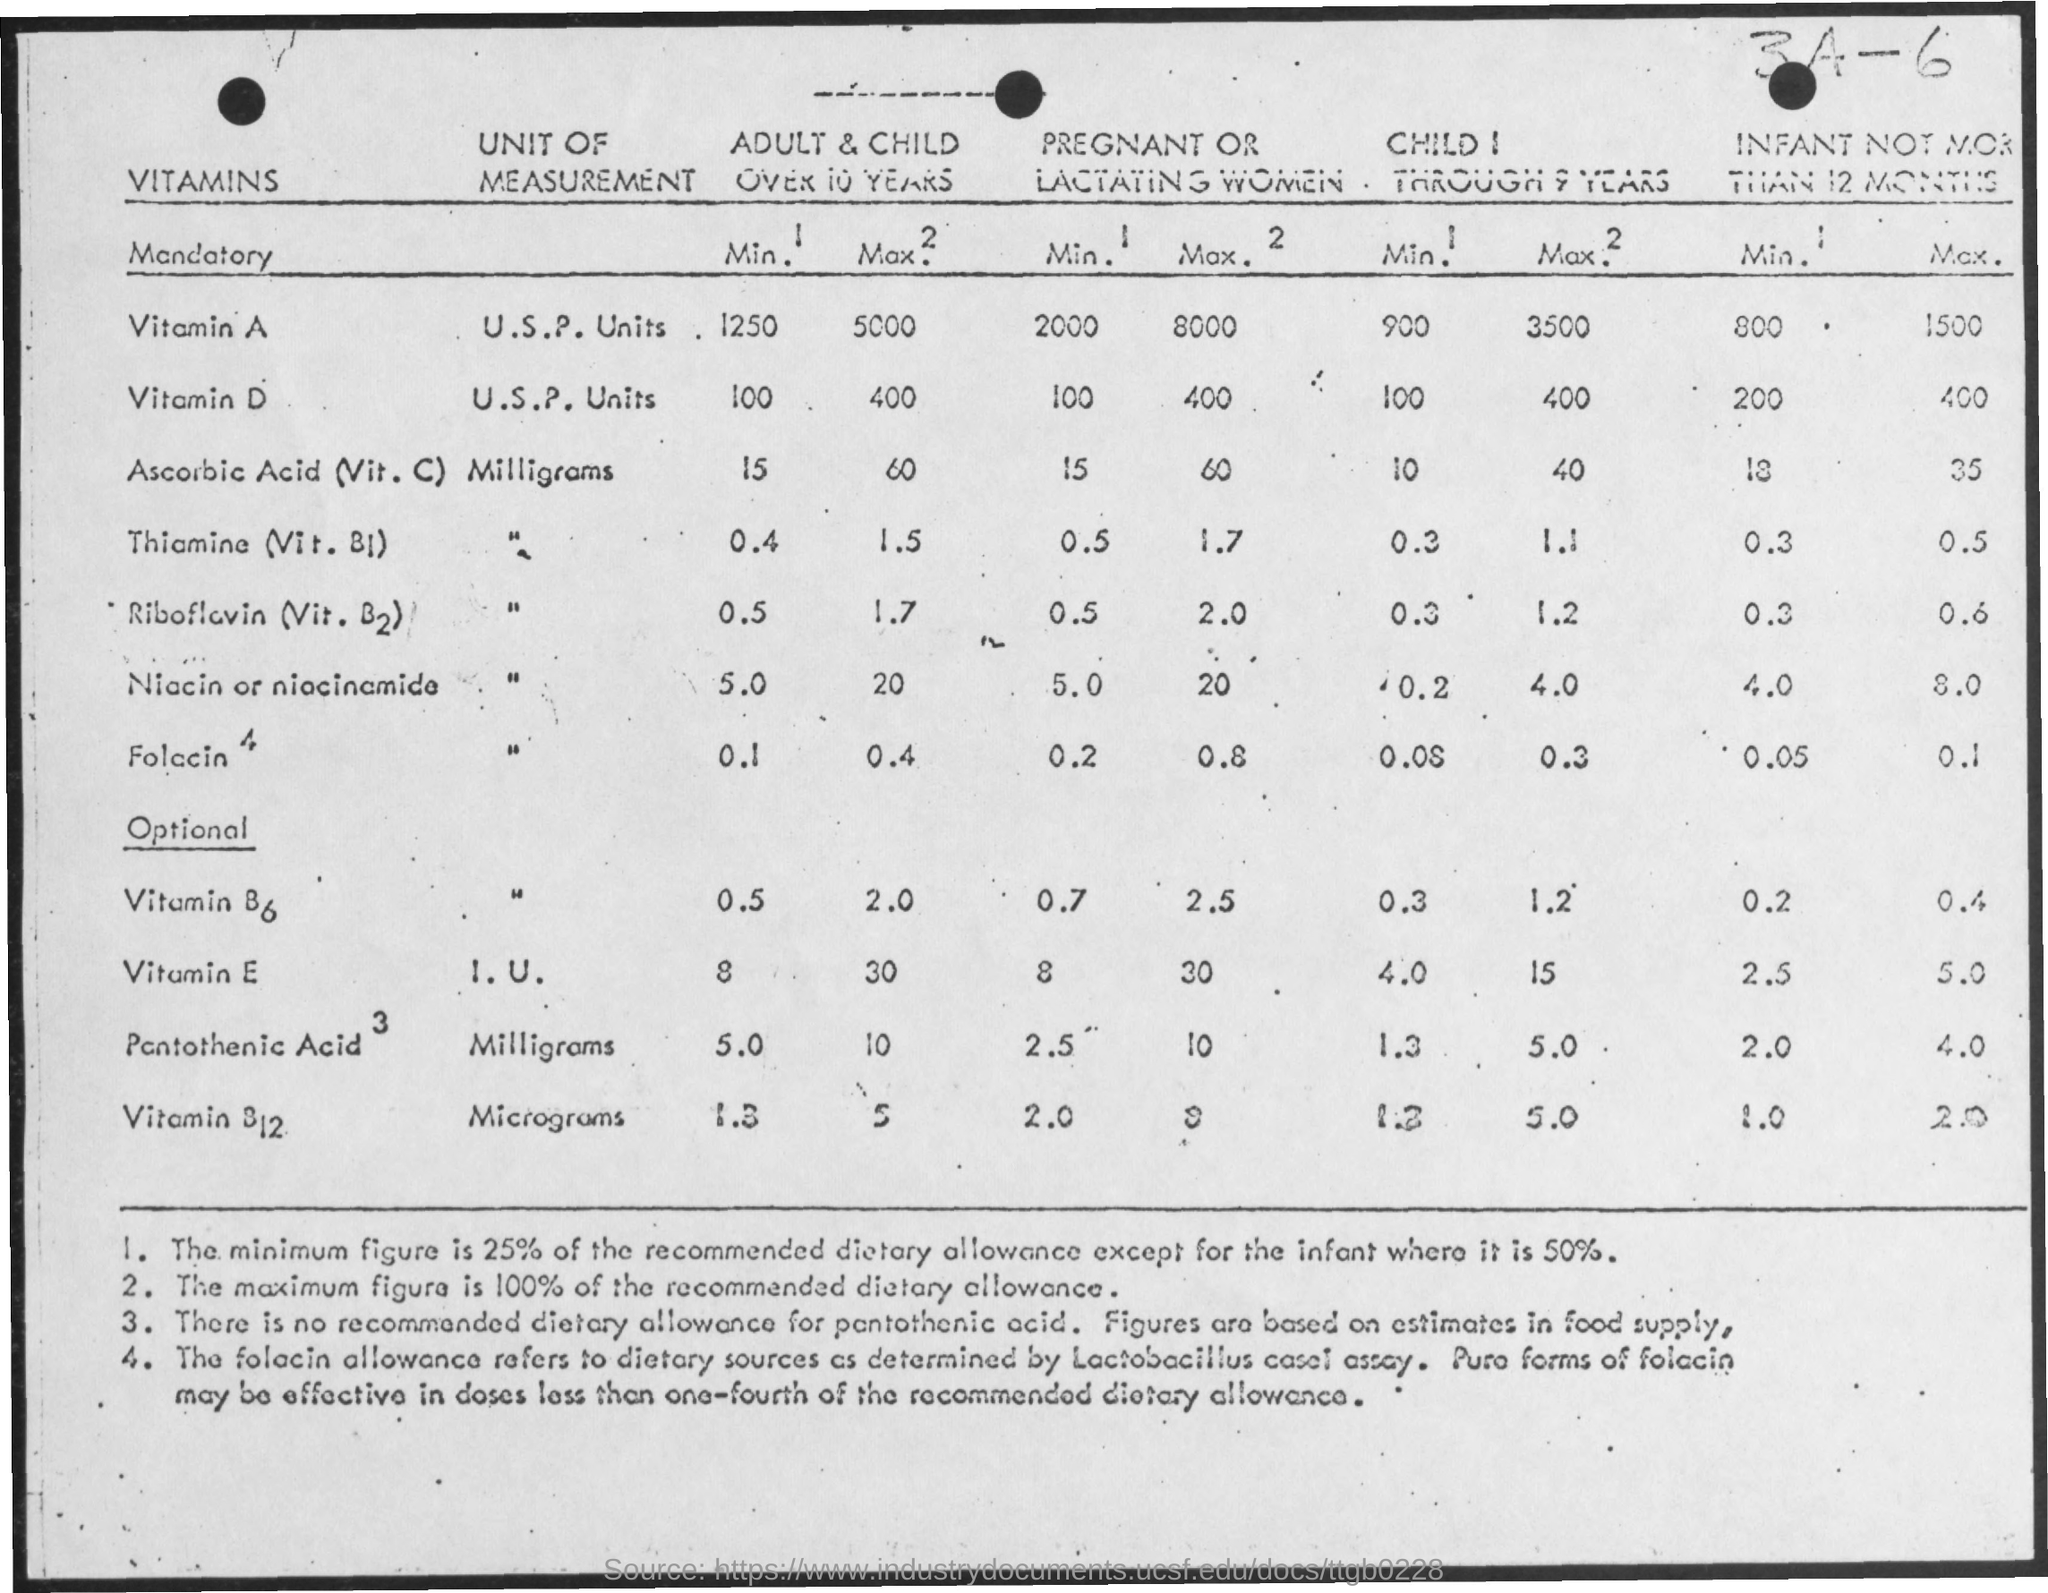What is the unit of measurement of Vitamin E?
Your answer should be very brief. I. u. What is the unit of measurement of Vitamin A?
Offer a terse response. U.s.p. units. What is the unit of measurement of Niacin?
Your answer should be compact. Milligrams. What is the minimum amount of vitamin A in pregnant women?
Your answer should be compact. 2000. What is the maximum amount of vitamin D in an infant not more than 12 months?
Offer a terse response. 400. What is the minimum amount of vitamin E in pregnant women?
Your answer should be compact. 8. 